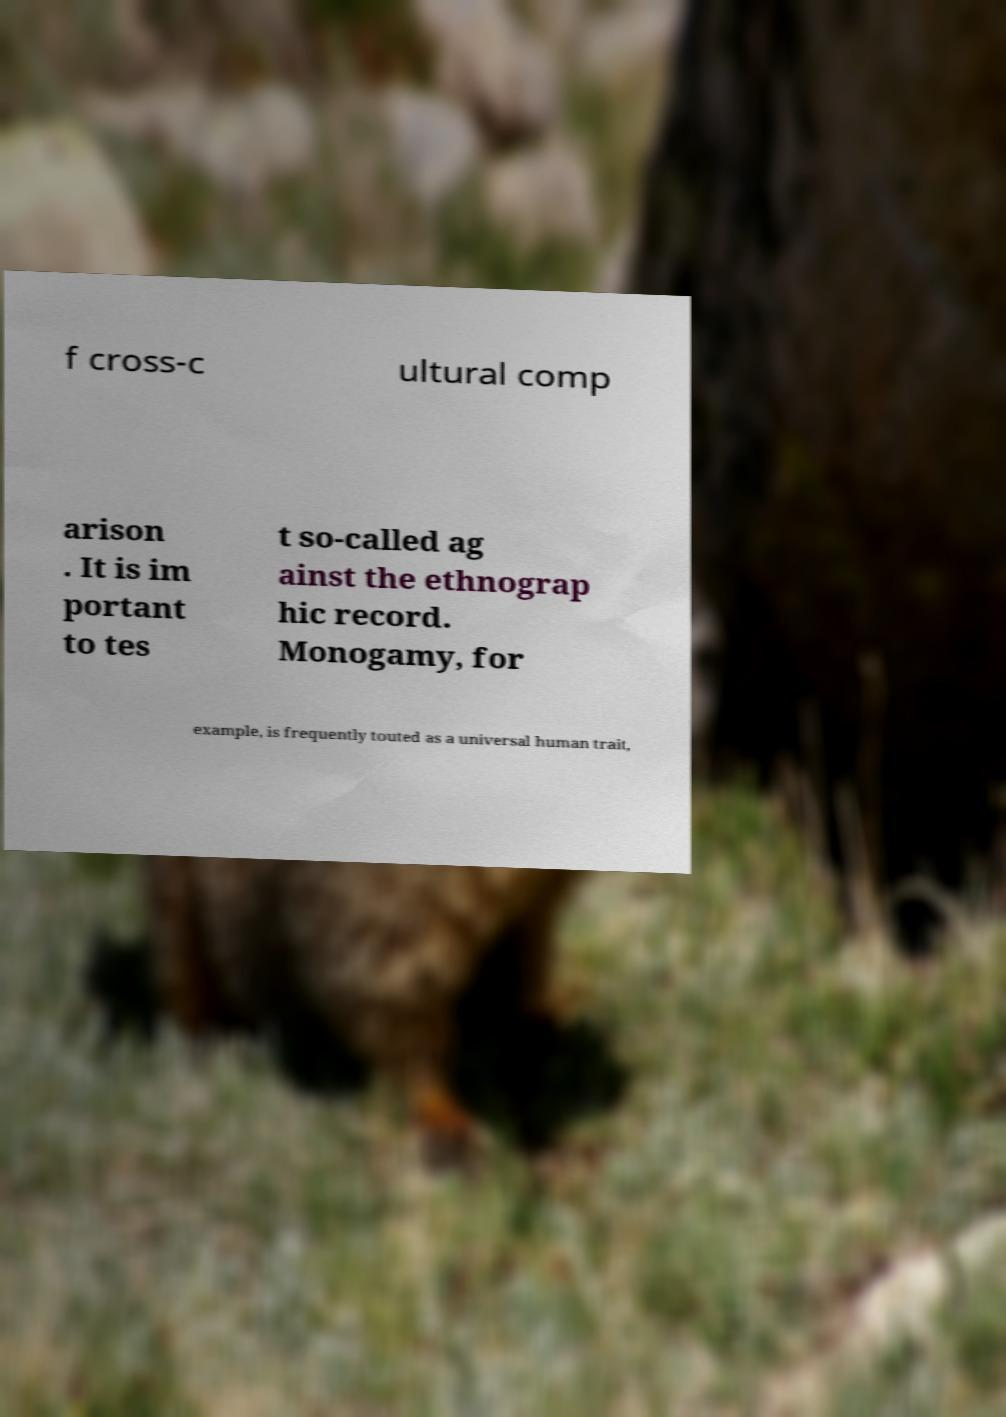Please identify and transcribe the text found in this image. f cross-c ultural comp arison . It is im portant to tes t so-called ag ainst the ethnograp hic record. Monogamy, for example, is frequently touted as a universal human trait, 